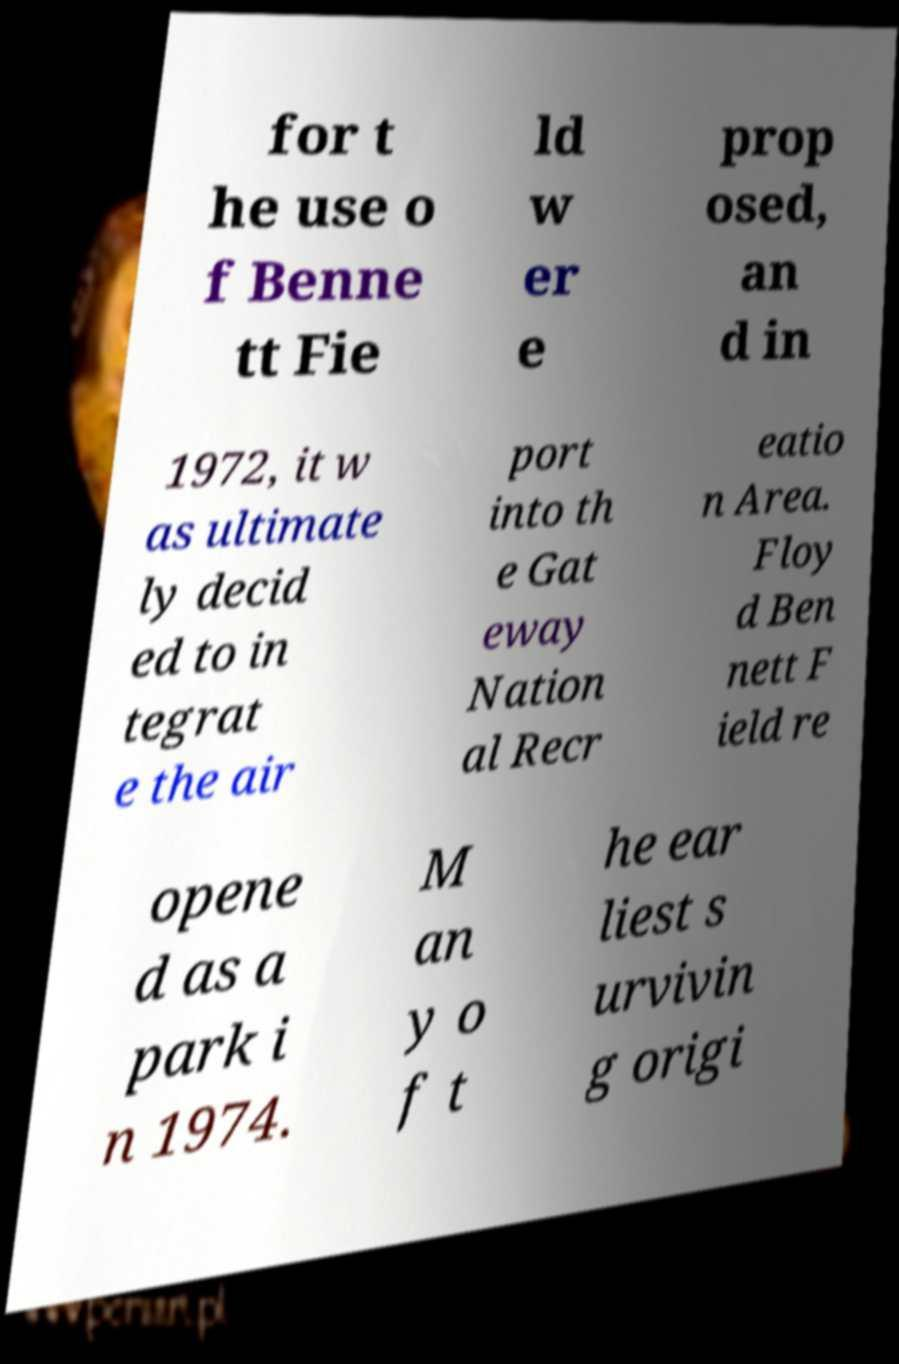Can you accurately transcribe the text from the provided image for me? for t he use o f Benne tt Fie ld w er e prop osed, an d in 1972, it w as ultimate ly decid ed to in tegrat e the air port into th e Gat eway Nation al Recr eatio n Area. Floy d Ben nett F ield re opene d as a park i n 1974. M an y o f t he ear liest s urvivin g origi 